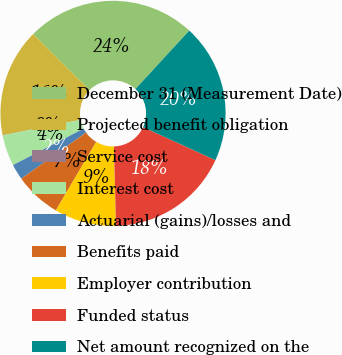Convert chart. <chart><loc_0><loc_0><loc_500><loc_500><pie_chart><fcel>December 31 (Measurement Date)<fcel>Projected benefit obligation<fcel>Service cost<fcel>Interest cost<fcel>Actuarial (gains)/losses and<fcel>Benefits paid<fcel>Employer contribution<fcel>Funded status<fcel>Net amount recognized on the<nl><fcel>24.4%<fcel>15.54%<fcel>0.03%<fcel>4.46%<fcel>2.25%<fcel>6.68%<fcel>8.9%<fcel>17.76%<fcel>19.97%<nl></chart> 